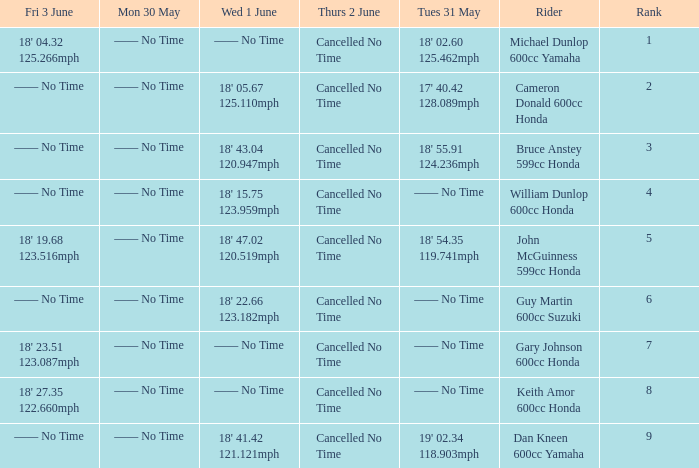What is the number of riders that had a Tues 31 May time of 18' 55.91 124.236mph? 1.0. 